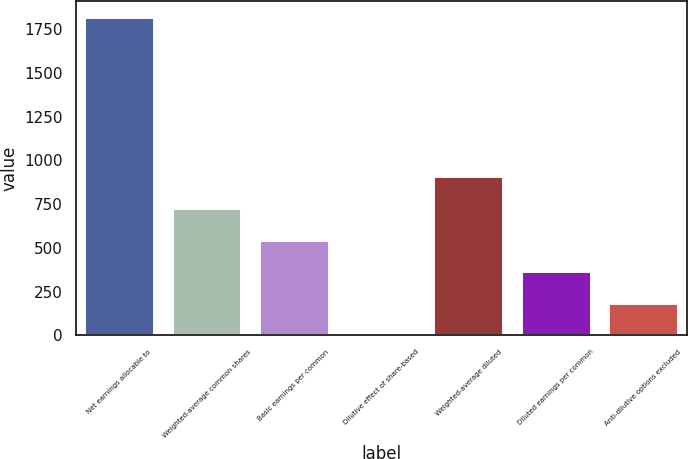Convert chart to OTSL. <chart><loc_0><loc_0><loc_500><loc_500><bar_chart><fcel>Net earnings allocable to<fcel>Weighted-average common shares<fcel>Basic earnings per common<fcel>Dilutive effect of share-based<fcel>Weighted-average diluted<fcel>Diluted earnings per common<fcel>Anti-dilutive options excluded<nl><fcel>1818<fcel>729<fcel>547.5<fcel>3<fcel>910.5<fcel>366<fcel>184.5<nl></chart> 